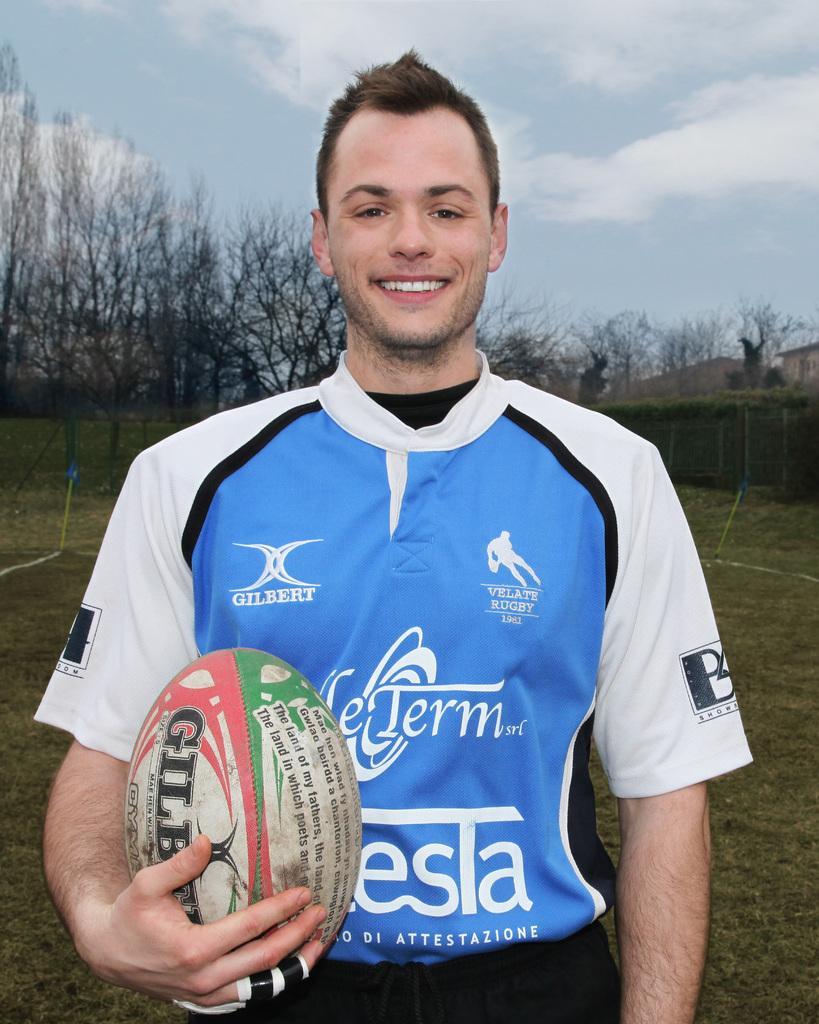Could you give a brief overview of what you see in this image? There is one man standing and holding a ball at the bottom of this image. We can see trees in the background. There is a sky at the top of this image. 